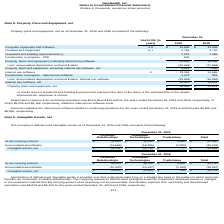From Nanthealth's financial document, What are the respective values of the gross carrying amounts of Customer Relationships and Developed Technologies in 2019? The document shows two values: 52,000 and 32,000. From the document: "Gross carrying amount $ 52,000 $ 32,000 $ 3,000 $ 87,000 Gross carrying amount $ 52,000 $ 32,000 $ 3,000 $ 87,000..." Also, What are the respective values of the accumulated amortization of Customer Relationships and Developed Technologies in 2019? The document shows two values: 13,866 and 18,286. From the document: "Accumulated amortization (13,866) (18,286) (3,000) (35,152) Accumulated amortization (13,866) (18,286) (3,000) (35,152)..." Also, What are the respective values of the net intangible assets of Customer Relationships and Developed Technologies in 2019? The document shows two values: $38,134 and $13,714. From the document: "Intangible assets, net $ 38,134 $ 13,714 $ — $ 51,848 Intangible assets, net $ 38,134 $ 13,714 $ — $ 51,848..." Also, can you calculate: What is the average gross carrying amounts of Customer Relationships and Developed Technologies in 2019? To answer this question, I need to perform calculations using the financial data. The calculation is: (52,000 + 32,000)/2 , which equals 42000. This is based on the information: "Gross carrying amount $ 52,000 $ 32,000 $ 3,000 $ 87,000 Gross carrying amount $ 52,000 $ 32,000 $ 3,000 $ 87,000..." The key data points involved are: 32,000, 52,000. Also, can you calculate: What is the average gross carrying amounts of Trade Name and Developed Technologies in 2019? To answer this question, I need to perform calculations using the financial data. The calculation is: (32,000 + 3,000)/2 , which equals 17500. This is based on the information: "Gross carrying amount $ 52,000 $ 32,000 $ 3,000 $ 87,000 Gross carrying amount $ 52,000 $ 32,000 $ 3,000 $ 87,000..." The key data points involved are: 3,000, 32,000. Also, can you calculate: What is the value of the Trade Name as a percentage of the total gross carrying amount in 2019? Based on the calculation: 3,000/87,000 , the result is 3.45 (percentage). This is based on the information: "Gross carrying amount $ 52,000 $ 32,000 $ 3,000 $ 87,000 Gross carrying amount $ 52,000 $ 32,000 $ 3,000 $ 87,000..." The key data points involved are: 3,000, 87,000. 